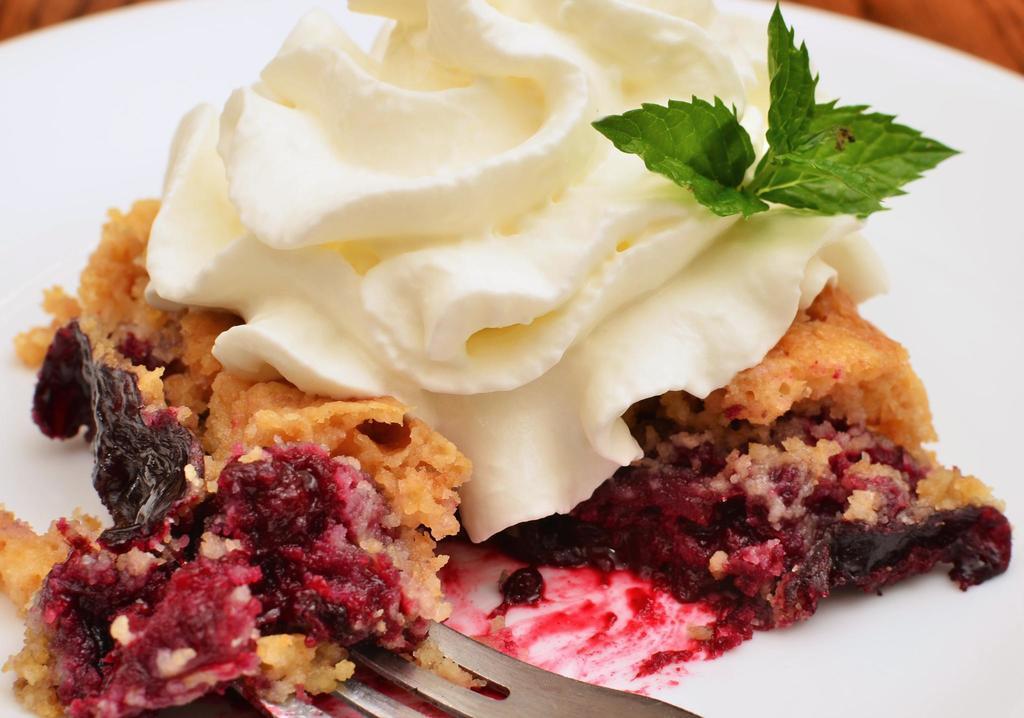Please provide a concise description of this image. In this picture I can see a white plate and I can see different types of food, which is of cream, red, white and green color. 